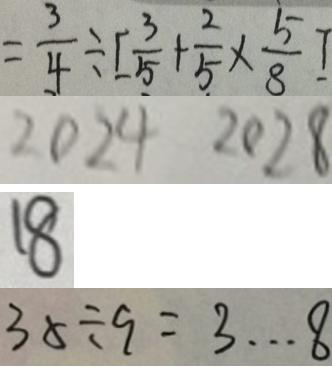Convert formula to latex. <formula><loc_0><loc_0><loc_500><loc_500>= \frac { 3 } { 4 } \div [ \frac { 3 } { 5 } + \frac { 2 } { 5 } \times \frac { 5 } { 8 } ] 
 2 0 2 4 2 0 2 8 
 1 8 
 3 5 \div 9 = 3 \cdots 8</formula> 